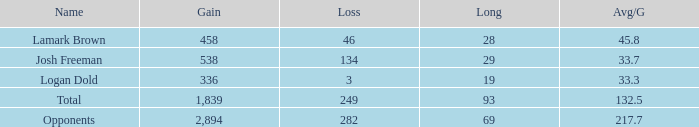Which avg/g has a name of josh freeman, and a loss beneath 134? None. 